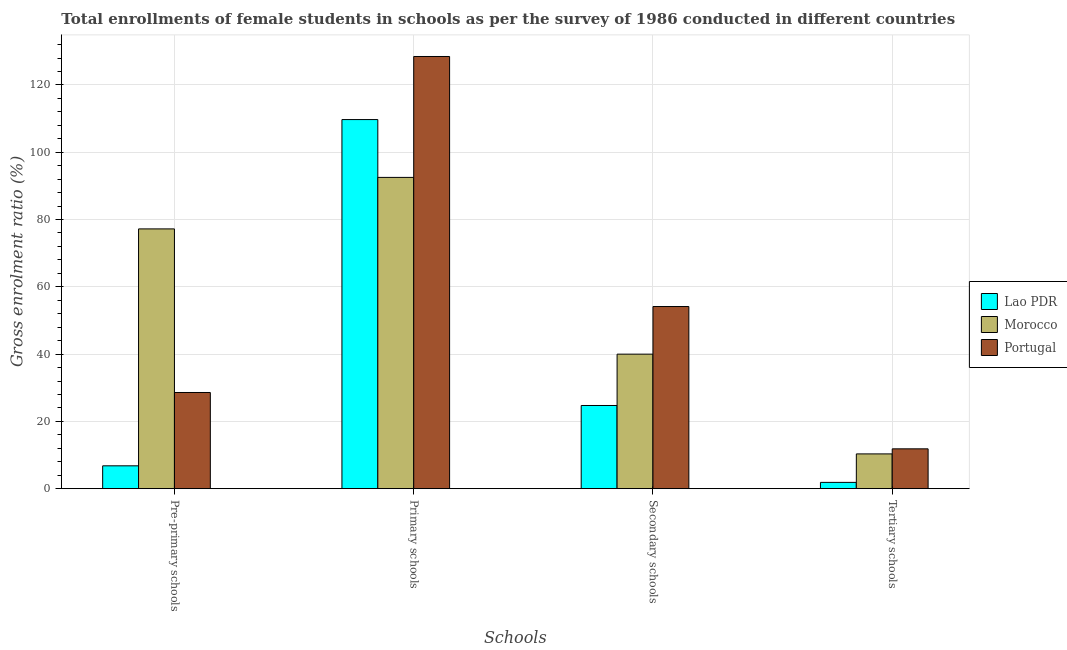How many different coloured bars are there?
Make the answer very short. 3. Are the number of bars per tick equal to the number of legend labels?
Offer a very short reply. Yes. Are the number of bars on each tick of the X-axis equal?
Your answer should be very brief. Yes. How many bars are there on the 3rd tick from the left?
Make the answer very short. 3. What is the label of the 4th group of bars from the left?
Make the answer very short. Tertiary schools. What is the gross enrolment ratio(female) in tertiary schools in Portugal?
Provide a succinct answer. 11.84. Across all countries, what is the maximum gross enrolment ratio(female) in pre-primary schools?
Provide a succinct answer. 77.21. Across all countries, what is the minimum gross enrolment ratio(female) in secondary schools?
Make the answer very short. 24.72. In which country was the gross enrolment ratio(female) in tertiary schools maximum?
Provide a succinct answer. Portugal. In which country was the gross enrolment ratio(female) in primary schools minimum?
Provide a succinct answer. Morocco. What is the total gross enrolment ratio(female) in secondary schools in the graph?
Provide a succinct answer. 118.85. What is the difference between the gross enrolment ratio(female) in secondary schools in Morocco and that in Portugal?
Offer a terse response. -14.15. What is the difference between the gross enrolment ratio(female) in secondary schools in Portugal and the gross enrolment ratio(female) in primary schools in Lao PDR?
Provide a short and direct response. -55.57. What is the average gross enrolment ratio(female) in secondary schools per country?
Offer a very short reply. 39.62. What is the difference between the gross enrolment ratio(female) in tertiary schools and gross enrolment ratio(female) in primary schools in Portugal?
Make the answer very short. -116.61. What is the ratio of the gross enrolment ratio(female) in pre-primary schools in Lao PDR to that in Morocco?
Make the answer very short. 0.09. Is the difference between the gross enrolment ratio(female) in primary schools in Portugal and Lao PDR greater than the difference between the gross enrolment ratio(female) in secondary schools in Portugal and Lao PDR?
Offer a terse response. No. What is the difference between the highest and the second highest gross enrolment ratio(female) in tertiary schools?
Offer a terse response. 1.51. What is the difference between the highest and the lowest gross enrolment ratio(female) in primary schools?
Offer a very short reply. 35.94. In how many countries, is the gross enrolment ratio(female) in secondary schools greater than the average gross enrolment ratio(female) in secondary schools taken over all countries?
Keep it short and to the point. 2. Is the sum of the gross enrolment ratio(female) in pre-primary schools in Morocco and Lao PDR greater than the maximum gross enrolment ratio(female) in secondary schools across all countries?
Make the answer very short. Yes. What does the 2nd bar from the left in Primary schools represents?
Keep it short and to the point. Morocco. What does the 1st bar from the right in Pre-primary schools represents?
Provide a short and direct response. Portugal. Is it the case that in every country, the sum of the gross enrolment ratio(female) in pre-primary schools and gross enrolment ratio(female) in primary schools is greater than the gross enrolment ratio(female) in secondary schools?
Make the answer very short. Yes. How many bars are there?
Your response must be concise. 12. Are all the bars in the graph horizontal?
Provide a short and direct response. No. How many countries are there in the graph?
Your answer should be very brief. 3. Are the values on the major ticks of Y-axis written in scientific E-notation?
Make the answer very short. No. Does the graph contain grids?
Your answer should be compact. Yes. Where does the legend appear in the graph?
Your answer should be very brief. Center right. How are the legend labels stacked?
Make the answer very short. Vertical. What is the title of the graph?
Give a very brief answer. Total enrollments of female students in schools as per the survey of 1986 conducted in different countries. What is the label or title of the X-axis?
Provide a succinct answer. Schools. What is the label or title of the Y-axis?
Ensure brevity in your answer.  Gross enrolment ratio (%). What is the Gross enrolment ratio (%) of Lao PDR in Pre-primary schools?
Give a very brief answer. 6.79. What is the Gross enrolment ratio (%) of Morocco in Pre-primary schools?
Keep it short and to the point. 77.21. What is the Gross enrolment ratio (%) in Portugal in Pre-primary schools?
Provide a succinct answer. 28.59. What is the Gross enrolment ratio (%) in Lao PDR in Primary schools?
Ensure brevity in your answer.  109.71. What is the Gross enrolment ratio (%) in Morocco in Primary schools?
Offer a very short reply. 92.52. What is the Gross enrolment ratio (%) of Portugal in Primary schools?
Your response must be concise. 128.46. What is the Gross enrolment ratio (%) in Lao PDR in Secondary schools?
Your answer should be very brief. 24.72. What is the Gross enrolment ratio (%) in Morocco in Secondary schools?
Your answer should be compact. 39.98. What is the Gross enrolment ratio (%) of Portugal in Secondary schools?
Your answer should be compact. 54.14. What is the Gross enrolment ratio (%) of Lao PDR in Tertiary schools?
Ensure brevity in your answer.  1.87. What is the Gross enrolment ratio (%) in Morocco in Tertiary schools?
Ensure brevity in your answer.  10.33. What is the Gross enrolment ratio (%) in Portugal in Tertiary schools?
Your answer should be compact. 11.84. Across all Schools, what is the maximum Gross enrolment ratio (%) of Lao PDR?
Provide a short and direct response. 109.71. Across all Schools, what is the maximum Gross enrolment ratio (%) in Morocco?
Ensure brevity in your answer.  92.52. Across all Schools, what is the maximum Gross enrolment ratio (%) of Portugal?
Your answer should be very brief. 128.46. Across all Schools, what is the minimum Gross enrolment ratio (%) in Lao PDR?
Ensure brevity in your answer.  1.87. Across all Schools, what is the minimum Gross enrolment ratio (%) of Morocco?
Your answer should be compact. 10.33. Across all Schools, what is the minimum Gross enrolment ratio (%) in Portugal?
Give a very brief answer. 11.84. What is the total Gross enrolment ratio (%) of Lao PDR in the graph?
Give a very brief answer. 143.09. What is the total Gross enrolment ratio (%) of Morocco in the graph?
Offer a terse response. 220.05. What is the total Gross enrolment ratio (%) in Portugal in the graph?
Ensure brevity in your answer.  223.03. What is the difference between the Gross enrolment ratio (%) of Lao PDR in Pre-primary schools and that in Primary schools?
Your response must be concise. -102.91. What is the difference between the Gross enrolment ratio (%) of Morocco in Pre-primary schools and that in Primary schools?
Offer a terse response. -15.31. What is the difference between the Gross enrolment ratio (%) in Portugal in Pre-primary schools and that in Primary schools?
Your response must be concise. -99.87. What is the difference between the Gross enrolment ratio (%) of Lao PDR in Pre-primary schools and that in Secondary schools?
Provide a succinct answer. -17.93. What is the difference between the Gross enrolment ratio (%) in Morocco in Pre-primary schools and that in Secondary schools?
Make the answer very short. 37.23. What is the difference between the Gross enrolment ratio (%) of Portugal in Pre-primary schools and that in Secondary schools?
Ensure brevity in your answer.  -25.55. What is the difference between the Gross enrolment ratio (%) in Lao PDR in Pre-primary schools and that in Tertiary schools?
Give a very brief answer. 4.92. What is the difference between the Gross enrolment ratio (%) of Morocco in Pre-primary schools and that in Tertiary schools?
Offer a very short reply. 66.88. What is the difference between the Gross enrolment ratio (%) in Portugal in Pre-primary schools and that in Tertiary schools?
Offer a very short reply. 16.75. What is the difference between the Gross enrolment ratio (%) of Lao PDR in Primary schools and that in Secondary schools?
Ensure brevity in your answer.  84.98. What is the difference between the Gross enrolment ratio (%) in Morocco in Primary schools and that in Secondary schools?
Provide a succinct answer. 52.53. What is the difference between the Gross enrolment ratio (%) of Portugal in Primary schools and that in Secondary schools?
Offer a very short reply. 74.32. What is the difference between the Gross enrolment ratio (%) of Lao PDR in Primary schools and that in Tertiary schools?
Keep it short and to the point. 107.83. What is the difference between the Gross enrolment ratio (%) of Morocco in Primary schools and that in Tertiary schools?
Give a very brief answer. 82.18. What is the difference between the Gross enrolment ratio (%) of Portugal in Primary schools and that in Tertiary schools?
Give a very brief answer. 116.61. What is the difference between the Gross enrolment ratio (%) in Lao PDR in Secondary schools and that in Tertiary schools?
Offer a terse response. 22.85. What is the difference between the Gross enrolment ratio (%) in Morocco in Secondary schools and that in Tertiary schools?
Make the answer very short. 29.65. What is the difference between the Gross enrolment ratio (%) of Portugal in Secondary schools and that in Tertiary schools?
Offer a very short reply. 42.3. What is the difference between the Gross enrolment ratio (%) of Lao PDR in Pre-primary schools and the Gross enrolment ratio (%) of Morocco in Primary schools?
Give a very brief answer. -85.72. What is the difference between the Gross enrolment ratio (%) of Lao PDR in Pre-primary schools and the Gross enrolment ratio (%) of Portugal in Primary schools?
Give a very brief answer. -121.66. What is the difference between the Gross enrolment ratio (%) of Morocco in Pre-primary schools and the Gross enrolment ratio (%) of Portugal in Primary schools?
Your response must be concise. -51.25. What is the difference between the Gross enrolment ratio (%) of Lao PDR in Pre-primary schools and the Gross enrolment ratio (%) of Morocco in Secondary schools?
Your answer should be very brief. -33.19. What is the difference between the Gross enrolment ratio (%) of Lao PDR in Pre-primary schools and the Gross enrolment ratio (%) of Portugal in Secondary schools?
Ensure brevity in your answer.  -47.35. What is the difference between the Gross enrolment ratio (%) in Morocco in Pre-primary schools and the Gross enrolment ratio (%) in Portugal in Secondary schools?
Provide a short and direct response. 23.07. What is the difference between the Gross enrolment ratio (%) in Lao PDR in Pre-primary schools and the Gross enrolment ratio (%) in Morocco in Tertiary schools?
Your answer should be very brief. -3.54. What is the difference between the Gross enrolment ratio (%) of Lao PDR in Pre-primary schools and the Gross enrolment ratio (%) of Portugal in Tertiary schools?
Your answer should be very brief. -5.05. What is the difference between the Gross enrolment ratio (%) in Morocco in Pre-primary schools and the Gross enrolment ratio (%) in Portugal in Tertiary schools?
Your answer should be very brief. 65.37. What is the difference between the Gross enrolment ratio (%) of Lao PDR in Primary schools and the Gross enrolment ratio (%) of Morocco in Secondary schools?
Your answer should be compact. 69.72. What is the difference between the Gross enrolment ratio (%) of Lao PDR in Primary schools and the Gross enrolment ratio (%) of Portugal in Secondary schools?
Your answer should be very brief. 55.57. What is the difference between the Gross enrolment ratio (%) of Morocco in Primary schools and the Gross enrolment ratio (%) of Portugal in Secondary schools?
Offer a very short reply. 38.38. What is the difference between the Gross enrolment ratio (%) of Lao PDR in Primary schools and the Gross enrolment ratio (%) of Morocco in Tertiary schools?
Provide a short and direct response. 99.37. What is the difference between the Gross enrolment ratio (%) in Lao PDR in Primary schools and the Gross enrolment ratio (%) in Portugal in Tertiary schools?
Offer a terse response. 97.86. What is the difference between the Gross enrolment ratio (%) of Morocco in Primary schools and the Gross enrolment ratio (%) of Portugal in Tertiary schools?
Provide a succinct answer. 80.67. What is the difference between the Gross enrolment ratio (%) in Lao PDR in Secondary schools and the Gross enrolment ratio (%) in Morocco in Tertiary schools?
Give a very brief answer. 14.39. What is the difference between the Gross enrolment ratio (%) in Lao PDR in Secondary schools and the Gross enrolment ratio (%) in Portugal in Tertiary schools?
Make the answer very short. 12.88. What is the difference between the Gross enrolment ratio (%) in Morocco in Secondary schools and the Gross enrolment ratio (%) in Portugal in Tertiary schools?
Make the answer very short. 28.14. What is the average Gross enrolment ratio (%) of Lao PDR per Schools?
Offer a terse response. 35.77. What is the average Gross enrolment ratio (%) of Morocco per Schools?
Provide a short and direct response. 55.01. What is the average Gross enrolment ratio (%) of Portugal per Schools?
Give a very brief answer. 55.76. What is the difference between the Gross enrolment ratio (%) in Lao PDR and Gross enrolment ratio (%) in Morocco in Pre-primary schools?
Your answer should be very brief. -70.42. What is the difference between the Gross enrolment ratio (%) of Lao PDR and Gross enrolment ratio (%) of Portugal in Pre-primary schools?
Give a very brief answer. -21.8. What is the difference between the Gross enrolment ratio (%) of Morocco and Gross enrolment ratio (%) of Portugal in Pre-primary schools?
Ensure brevity in your answer.  48.62. What is the difference between the Gross enrolment ratio (%) of Lao PDR and Gross enrolment ratio (%) of Morocco in Primary schools?
Your response must be concise. 17.19. What is the difference between the Gross enrolment ratio (%) in Lao PDR and Gross enrolment ratio (%) in Portugal in Primary schools?
Provide a succinct answer. -18.75. What is the difference between the Gross enrolment ratio (%) of Morocco and Gross enrolment ratio (%) of Portugal in Primary schools?
Ensure brevity in your answer.  -35.94. What is the difference between the Gross enrolment ratio (%) of Lao PDR and Gross enrolment ratio (%) of Morocco in Secondary schools?
Make the answer very short. -15.26. What is the difference between the Gross enrolment ratio (%) in Lao PDR and Gross enrolment ratio (%) in Portugal in Secondary schools?
Ensure brevity in your answer.  -29.42. What is the difference between the Gross enrolment ratio (%) of Morocco and Gross enrolment ratio (%) of Portugal in Secondary schools?
Offer a terse response. -14.15. What is the difference between the Gross enrolment ratio (%) of Lao PDR and Gross enrolment ratio (%) of Morocco in Tertiary schools?
Provide a succinct answer. -8.46. What is the difference between the Gross enrolment ratio (%) of Lao PDR and Gross enrolment ratio (%) of Portugal in Tertiary schools?
Give a very brief answer. -9.97. What is the difference between the Gross enrolment ratio (%) of Morocco and Gross enrolment ratio (%) of Portugal in Tertiary schools?
Keep it short and to the point. -1.51. What is the ratio of the Gross enrolment ratio (%) of Lao PDR in Pre-primary schools to that in Primary schools?
Give a very brief answer. 0.06. What is the ratio of the Gross enrolment ratio (%) of Morocco in Pre-primary schools to that in Primary schools?
Your answer should be very brief. 0.83. What is the ratio of the Gross enrolment ratio (%) in Portugal in Pre-primary schools to that in Primary schools?
Your response must be concise. 0.22. What is the ratio of the Gross enrolment ratio (%) of Lao PDR in Pre-primary schools to that in Secondary schools?
Offer a very short reply. 0.27. What is the ratio of the Gross enrolment ratio (%) of Morocco in Pre-primary schools to that in Secondary schools?
Make the answer very short. 1.93. What is the ratio of the Gross enrolment ratio (%) of Portugal in Pre-primary schools to that in Secondary schools?
Ensure brevity in your answer.  0.53. What is the ratio of the Gross enrolment ratio (%) of Lao PDR in Pre-primary schools to that in Tertiary schools?
Give a very brief answer. 3.63. What is the ratio of the Gross enrolment ratio (%) of Morocco in Pre-primary schools to that in Tertiary schools?
Your answer should be very brief. 7.47. What is the ratio of the Gross enrolment ratio (%) in Portugal in Pre-primary schools to that in Tertiary schools?
Provide a succinct answer. 2.41. What is the ratio of the Gross enrolment ratio (%) of Lao PDR in Primary schools to that in Secondary schools?
Keep it short and to the point. 4.44. What is the ratio of the Gross enrolment ratio (%) in Morocco in Primary schools to that in Secondary schools?
Ensure brevity in your answer.  2.31. What is the ratio of the Gross enrolment ratio (%) in Portugal in Primary schools to that in Secondary schools?
Your response must be concise. 2.37. What is the ratio of the Gross enrolment ratio (%) in Lao PDR in Primary schools to that in Tertiary schools?
Give a very brief answer. 58.64. What is the ratio of the Gross enrolment ratio (%) of Morocco in Primary schools to that in Tertiary schools?
Ensure brevity in your answer.  8.95. What is the ratio of the Gross enrolment ratio (%) of Portugal in Primary schools to that in Tertiary schools?
Your answer should be very brief. 10.85. What is the ratio of the Gross enrolment ratio (%) of Lao PDR in Secondary schools to that in Tertiary schools?
Offer a terse response. 13.21. What is the ratio of the Gross enrolment ratio (%) of Morocco in Secondary schools to that in Tertiary schools?
Give a very brief answer. 3.87. What is the ratio of the Gross enrolment ratio (%) in Portugal in Secondary schools to that in Tertiary schools?
Offer a very short reply. 4.57. What is the difference between the highest and the second highest Gross enrolment ratio (%) in Lao PDR?
Provide a short and direct response. 84.98. What is the difference between the highest and the second highest Gross enrolment ratio (%) of Morocco?
Offer a terse response. 15.31. What is the difference between the highest and the second highest Gross enrolment ratio (%) in Portugal?
Provide a succinct answer. 74.32. What is the difference between the highest and the lowest Gross enrolment ratio (%) in Lao PDR?
Give a very brief answer. 107.83. What is the difference between the highest and the lowest Gross enrolment ratio (%) in Morocco?
Your response must be concise. 82.18. What is the difference between the highest and the lowest Gross enrolment ratio (%) in Portugal?
Your answer should be compact. 116.61. 